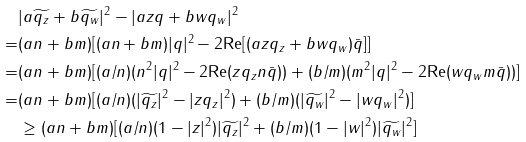<formula> <loc_0><loc_0><loc_500><loc_500>& | a \widetilde { q _ { z } } + b \widetilde { q _ { w } } | ^ { 2 } - | a z q + b w q _ { w } | ^ { 2 } \\ = & ( a n + b m ) [ ( a n + b m ) | q | ^ { 2 } - 2 \text {Re} [ ( a z q _ { z } + b w q _ { w } ) \bar { q } ] ] \\ = & ( a n + b m ) [ ( a / n ) ( n ^ { 2 } | q | ^ { 2 } - 2 \text {Re} ( z q _ { z } n \bar { q } ) ) + ( b / m ) ( m ^ { 2 } | q | ^ { 2 } - 2 \text {Re} ( w q _ { w } m \bar { q } ) ) ] \\ = & ( a n + b m ) [ ( a / n ) ( | \widetilde { q _ { z } } | ^ { 2 } - | z q _ { z } | ^ { 2 } ) + ( b / m ) ( | \widetilde { q _ { w } } | ^ { 2 } - | w q _ { w } | ^ { 2 } ) ] \\ & \geq ( a n + b m ) [ ( a / n ) ( 1 - | z | ^ { 2 } ) | \widetilde { q _ { z } } | ^ { 2 } + ( b / m ) ( 1 - | w | ^ { 2 } ) | \widetilde { q _ { w } } | ^ { 2 } ]</formula> 